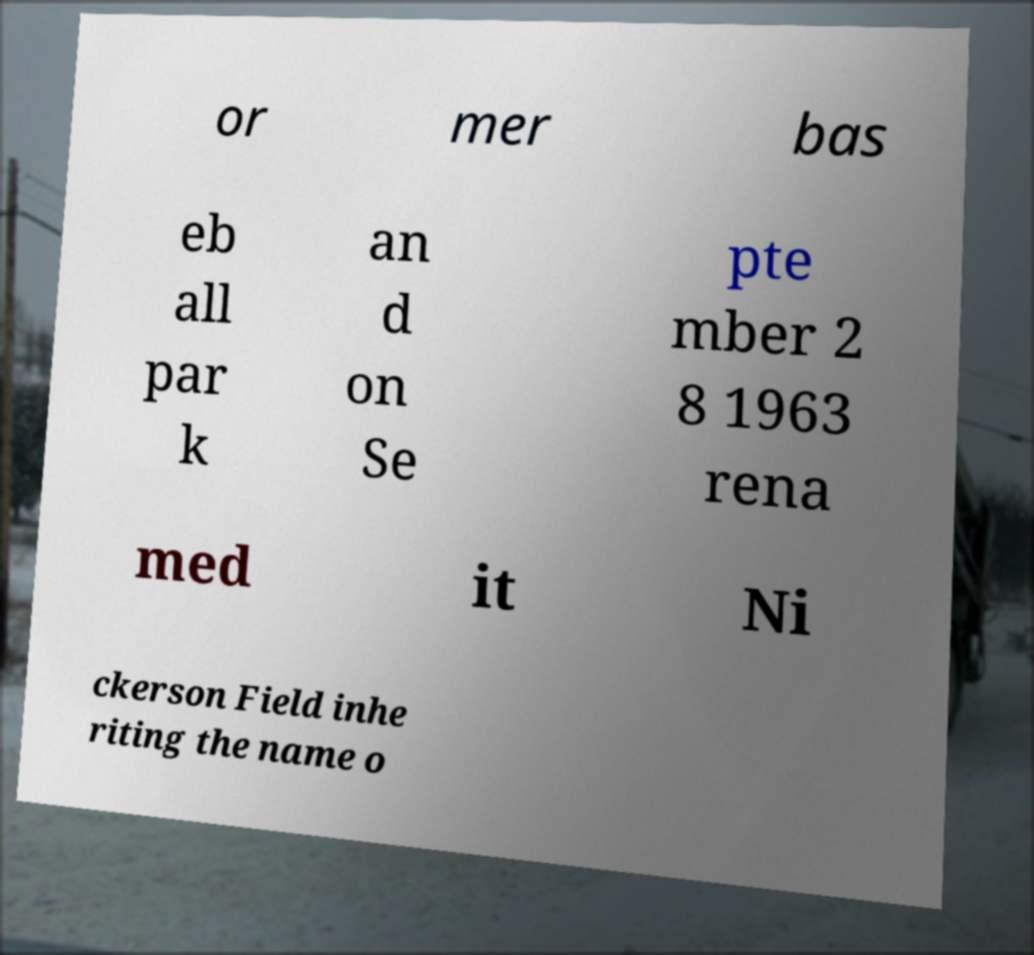Can you read and provide the text displayed in the image?This photo seems to have some interesting text. Can you extract and type it out for me? or mer bas eb all par k an d on Se pte mber 2 8 1963 rena med it Ni ckerson Field inhe riting the name o 